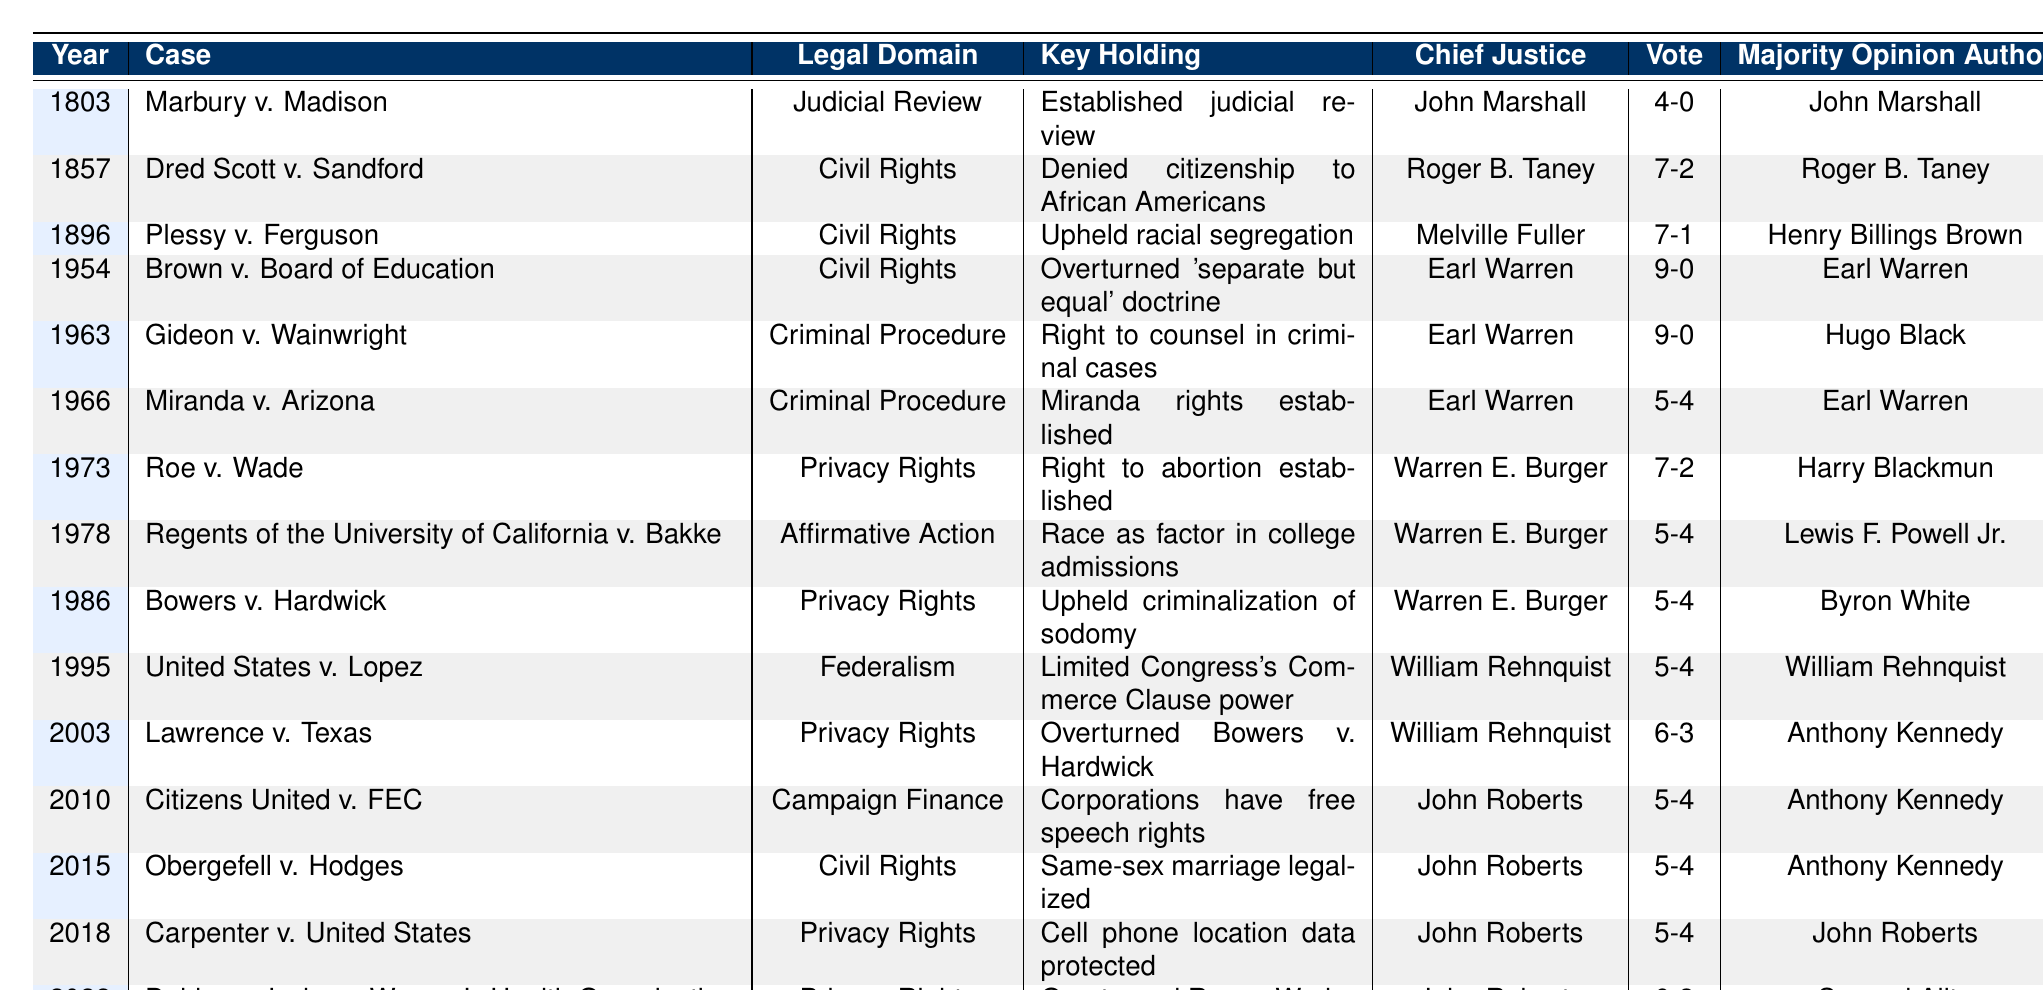What year was "Brown v. Board of Education" decided? The table lists "Brown v. Board of Education" and indicates it was decided in the year 1954.
Answer: 1954 Who was the Chief Justice during the case "Gideon v. Wainwright"? According to the table, "Gideon v. Wainwright" was decided under Chief Justice Earl Warren.
Answer: Earl Warren How many cases were decided by a vote of 9-0? From the table, the cases decided by a vote of 9-0 are "Brown v. Board of Education" and "Gideon v. Wainwright," totaling 2 cases.
Answer: 2 Did "Roe v. Wade" establish a right to abortion? The table indicates that the key holding for "Roe v. Wade" is the establishment of the right to abortion, confirming the fact.
Answer: Yes Which case overturned a previous ruling related to privacy rights? The table shows that "Lawrence v. Texas" overturned "Bowers v. Hardwick," thus it is the case in question.
Answer: Lawrence v. Texas What percentage of cases in the table fall under the legal domain of "Civil Rights"? There are 6 cases categorized as "Civil Rights" out of a total of 15 cases (6/15 = 0.4), which corresponds to 40%.
Answer: 40% Who wrote the majority opinion for "Citizens United v. FEC"? The table identifies Anthony Kennedy as the author of the majority opinion for "Citizens United v. FEC."
Answer: Anthony Kennedy How many cases listed were decided in the 21st century? The cases are "United States v. Lopez" (1995), "Lawrence v. Texas" (2003), "Citizens United v. FEC" (2010), "Obergefell v. Hodges" (2015), "Carpenter v. United States" (2018), and "Dobbs v. Jackson Women's Health Organization" (2022), making a total of 6 cases decided in the 21st century.
Answer: 6 What is the trend in the legal domain for cases decided between 1973 and 2022? Reviewing the table, the cases decided between 1973 and 2022 include "Privacy Rights" (5 instances), "Civil Rights" (2 instances), and "Affirmative Action" (1 instance), showing a prevalence of Privacy Rights.
Answer: Privacy Rights Which Chief Justice presided over the most Supreme Court cases listed? A review of the table reveals that John Roberts presided over the most cases listed with a total of 5 cases: "Citizens United v. FEC," "Obergefell v. Hodges," "Carpenter v. United States," and "Dobbs v. Jackson Women's Health Organization."
Answer: John Roberts 